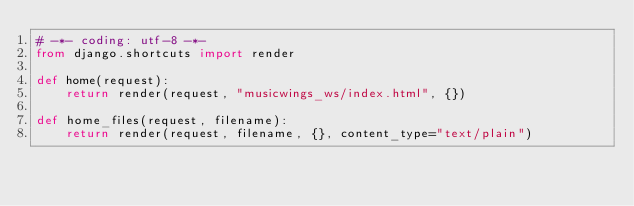<code> <loc_0><loc_0><loc_500><loc_500><_Python_># -*- coding: utf-8 -*-
from django.shortcuts import render

def home(request):
	return render(request, "musicwings_ws/index.html", {})

def home_files(request, filename):
	return render(request, filename, {}, content_type="text/plain")</code> 